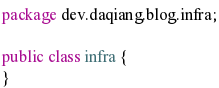<code> <loc_0><loc_0><loc_500><loc_500><_Java_>package dev.daqiang.blog.infra;

public class infra {
}
</code> 